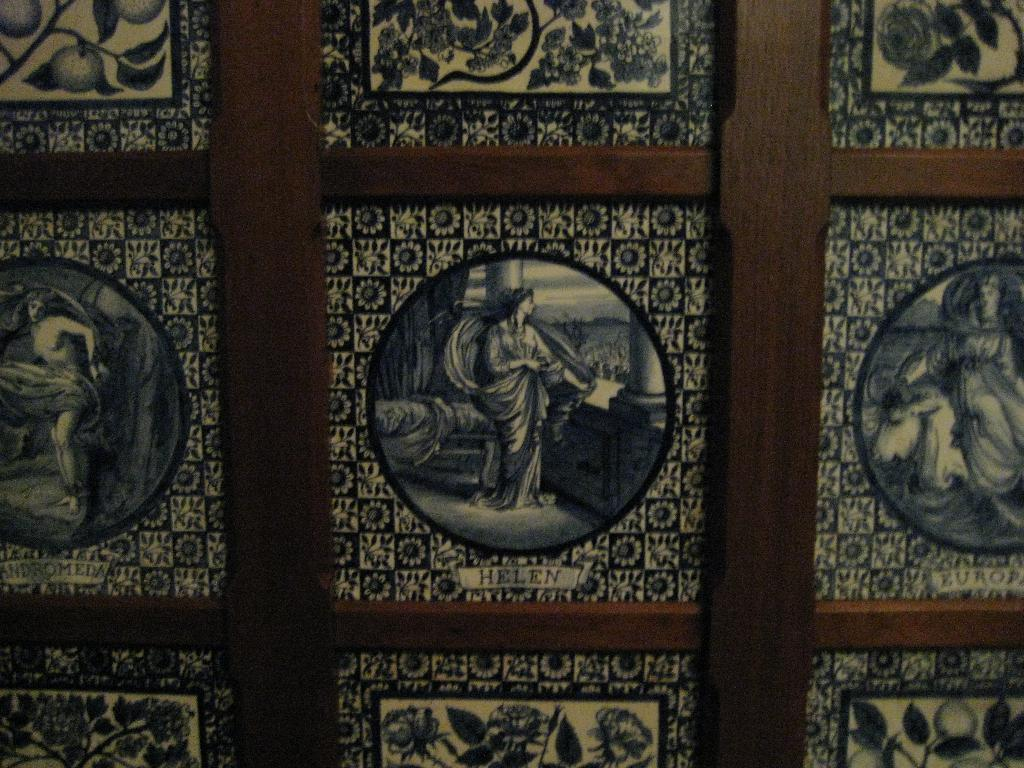What is the main subject of the image? The main subject of the image is a board with frames attached to it. What colors can be seen on the board? The board is in black and brown color. What type of animals can be seen in the zoo in the image? There is no zoo present in the image; it features a board with frames attached to it. What is the effect of the cave on the board in the image? There is no cave present in the image, so it cannot have any effect on the board. 